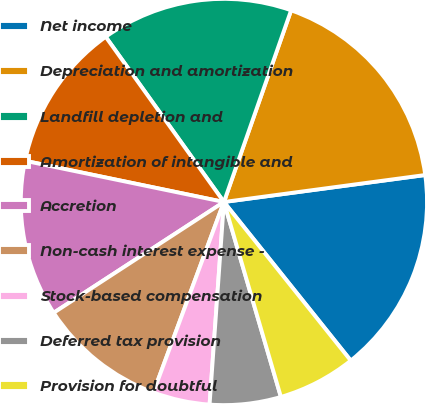Convert chart to OTSL. <chart><loc_0><loc_0><loc_500><loc_500><pie_chart><fcel>Net income<fcel>Depreciation and amortization<fcel>Landfill depletion and<fcel>Amortization of intangible and<fcel>Accretion<fcel>Non-cash interest expense -<fcel>Stock-based compensation<fcel>Deferred tax provision<fcel>Provision for doubtful<nl><fcel>16.38%<fcel>17.51%<fcel>15.25%<fcel>11.86%<fcel>12.43%<fcel>10.17%<fcel>4.52%<fcel>5.65%<fcel>6.21%<nl></chart> 